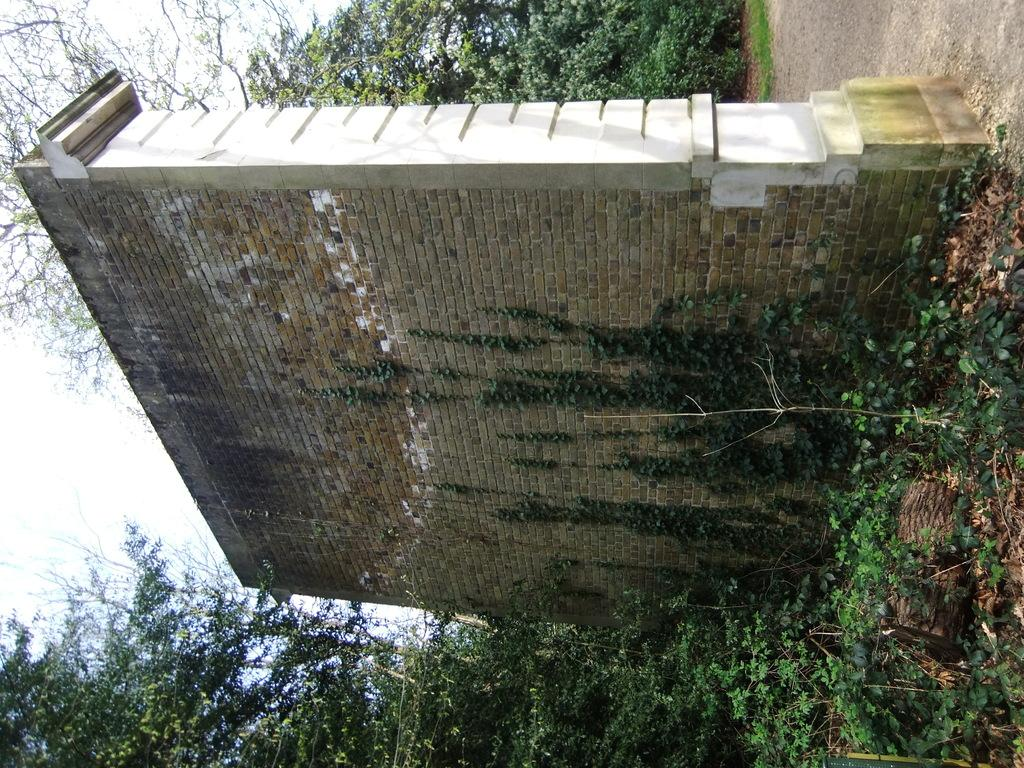What type of structure is visible in the image? There is a brick wall in the image. What is attached to the brick wall? There are plants on the wall. What can be seen on the sides of the wall? There are trees on the sides of the wall. What is visible on the left side of the image? The sky is visible on the left side of the image. What type of pathway is present in the image? There is a road in the right top corner of the image. What type of industry is being attacked by the police in the image? There is no industry or police present in the image; it features a brick wall with plants, trees, and a road. 